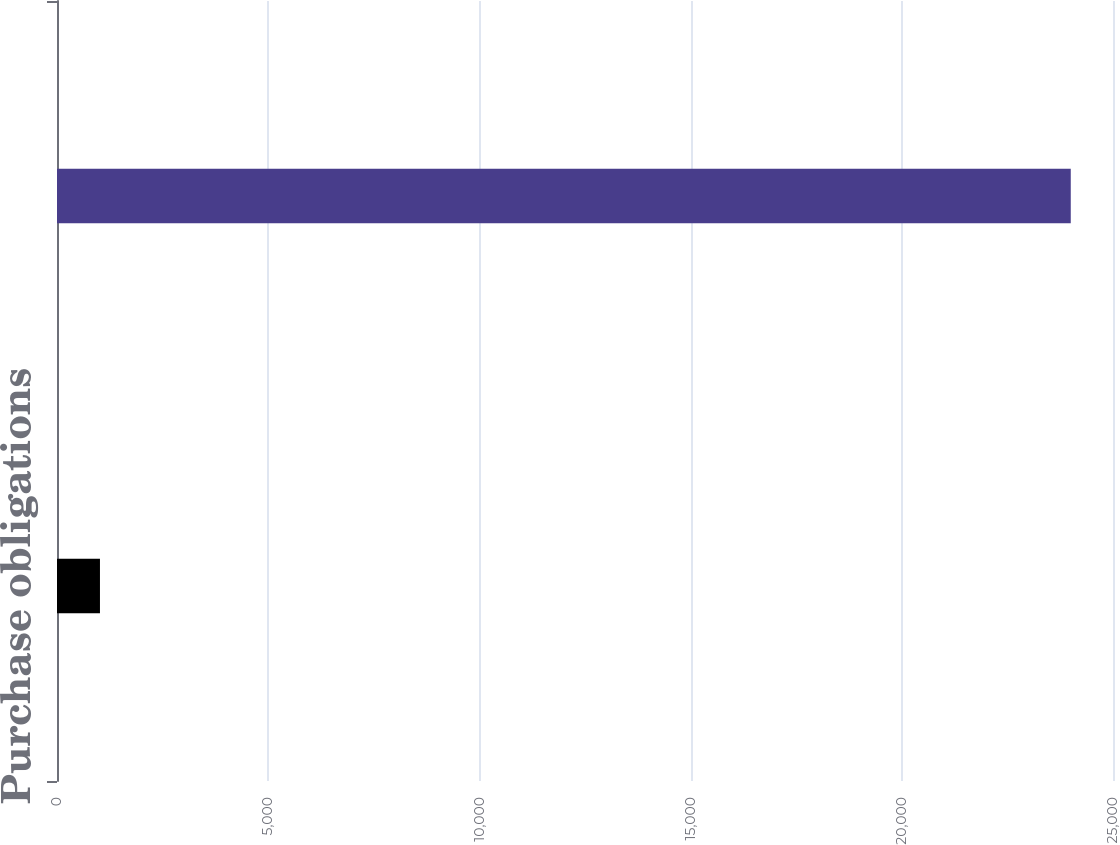Convert chart. <chart><loc_0><loc_0><loc_500><loc_500><bar_chart><fcel>Purchase obligations<fcel>ICANN agreement<nl><fcel>1017<fcel>24000<nl></chart> 